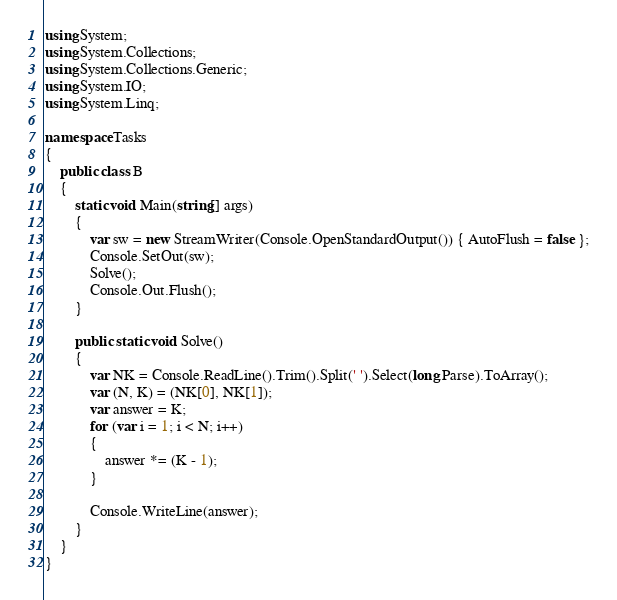<code> <loc_0><loc_0><loc_500><loc_500><_C#_>using System;
using System.Collections;
using System.Collections.Generic;
using System.IO;
using System.Linq;

namespace Tasks
{
    public class B
    {
        static void Main(string[] args)
        {
            var sw = new StreamWriter(Console.OpenStandardOutput()) { AutoFlush = false };
            Console.SetOut(sw);
            Solve();
            Console.Out.Flush();
        }

        public static void Solve()
        {
            var NK = Console.ReadLine().Trim().Split(' ').Select(long.Parse).ToArray();
            var (N, K) = (NK[0], NK[1]);
            var answer = K;
            for (var i = 1; i < N; i++)
            {
                answer *= (K - 1);
            }

            Console.WriteLine(answer);
        }
    }
}
</code> 